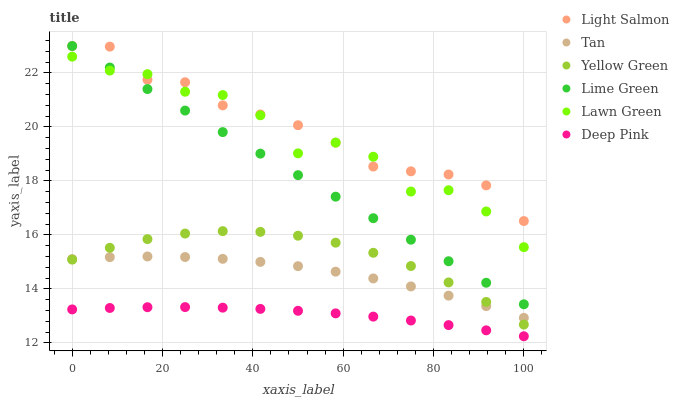Does Deep Pink have the minimum area under the curve?
Answer yes or no. Yes. Does Light Salmon have the maximum area under the curve?
Answer yes or no. Yes. Does Light Salmon have the minimum area under the curve?
Answer yes or no. No. Does Deep Pink have the maximum area under the curve?
Answer yes or no. No. Is Lime Green the smoothest?
Answer yes or no. Yes. Is Lawn Green the roughest?
Answer yes or no. Yes. Is Light Salmon the smoothest?
Answer yes or no. No. Is Light Salmon the roughest?
Answer yes or no. No. Does Deep Pink have the lowest value?
Answer yes or no. Yes. Does Light Salmon have the lowest value?
Answer yes or no. No. Does Lime Green have the highest value?
Answer yes or no. Yes. Does Deep Pink have the highest value?
Answer yes or no. No. Is Deep Pink less than Lawn Green?
Answer yes or no. Yes. Is Light Salmon greater than Yellow Green?
Answer yes or no. Yes. Does Tan intersect Yellow Green?
Answer yes or no. Yes. Is Tan less than Yellow Green?
Answer yes or no. No. Is Tan greater than Yellow Green?
Answer yes or no. No. Does Deep Pink intersect Lawn Green?
Answer yes or no. No. 